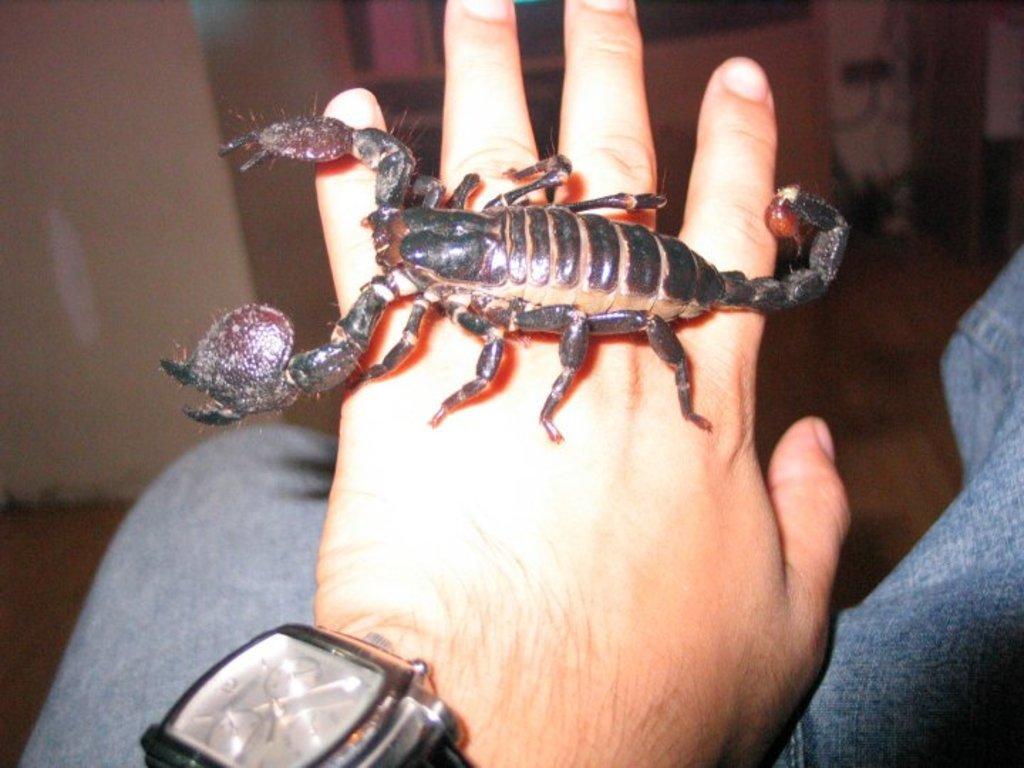Describe this image in one or two sentences. In this picture I can see a black color scorpion on the human hand and he wore a wrist watch. 